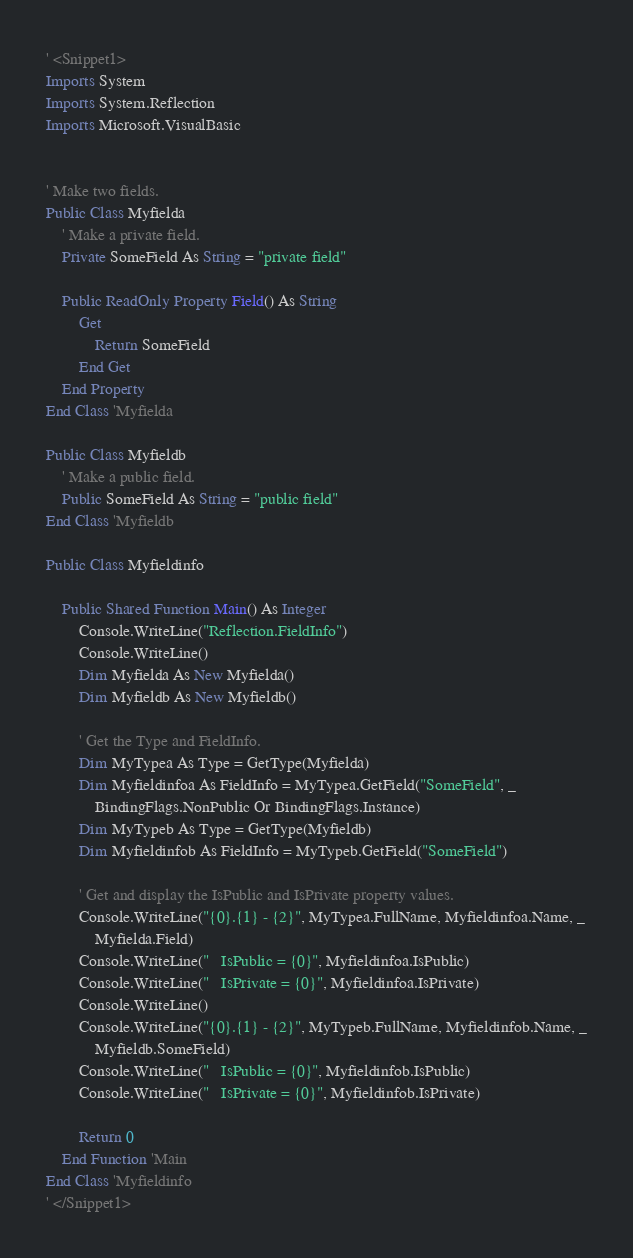<code> <loc_0><loc_0><loc_500><loc_500><_VisualBasic_>' <Snippet1>
Imports System
Imports System.Reflection
Imports Microsoft.VisualBasic


' Make two fields.
Public Class Myfielda
    ' Make a private field.
    Private SomeField As String = "private field"

    Public ReadOnly Property Field() As String
        Get
            Return SomeField
        End Get
    End Property
End Class 'Myfielda

Public Class Myfieldb
    ' Make a public field.
    Public SomeField As String = "public field"
End Class 'Myfieldb

Public Class Myfieldinfo

    Public Shared Function Main() As Integer
        Console.WriteLine("Reflection.FieldInfo")
        Console.WriteLine()
        Dim Myfielda As New Myfielda()
        Dim Myfieldb As New Myfieldb()

        ' Get the Type and FieldInfo.
        Dim MyTypea As Type = GetType(Myfielda)
        Dim Myfieldinfoa As FieldInfo = MyTypea.GetField("SomeField", _
            BindingFlags.NonPublic Or BindingFlags.Instance)
        Dim MyTypeb As Type = GetType(Myfieldb)
        Dim Myfieldinfob As FieldInfo = MyTypeb.GetField("SomeField")

        ' Get and display the IsPublic and IsPrivate property values.
        Console.WriteLine("{0}.{1} - {2}", MyTypea.FullName, Myfieldinfoa.Name, _
            Myfielda.Field)
        Console.WriteLine("   IsPublic = {0}", Myfieldinfoa.IsPublic)
        Console.WriteLine("   IsPrivate = {0}", Myfieldinfoa.IsPrivate)
        Console.WriteLine()
        Console.WriteLine("{0}.{1} - {2}", MyTypeb.FullName, Myfieldinfob.Name, _
            Myfieldb.SomeField)
        Console.WriteLine("   IsPublic = {0}", Myfieldinfob.IsPublic)
        Console.WriteLine("   IsPrivate = {0}", Myfieldinfob.IsPrivate)

        Return 0
    End Function 'Main
End Class 'Myfieldinfo
' </Snippet1></code> 